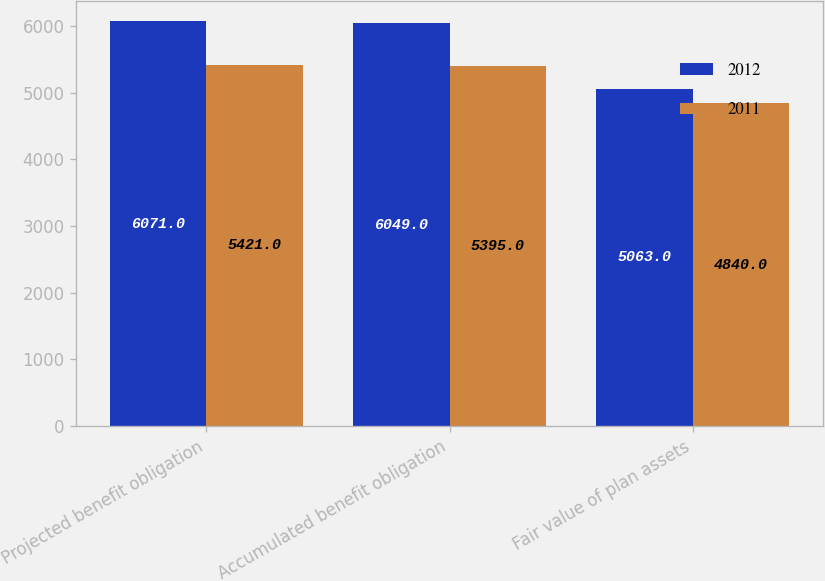Convert chart. <chart><loc_0><loc_0><loc_500><loc_500><stacked_bar_chart><ecel><fcel>Projected benefit obligation<fcel>Accumulated benefit obligation<fcel>Fair value of plan assets<nl><fcel>2012<fcel>6071<fcel>6049<fcel>5063<nl><fcel>2011<fcel>5421<fcel>5395<fcel>4840<nl></chart> 